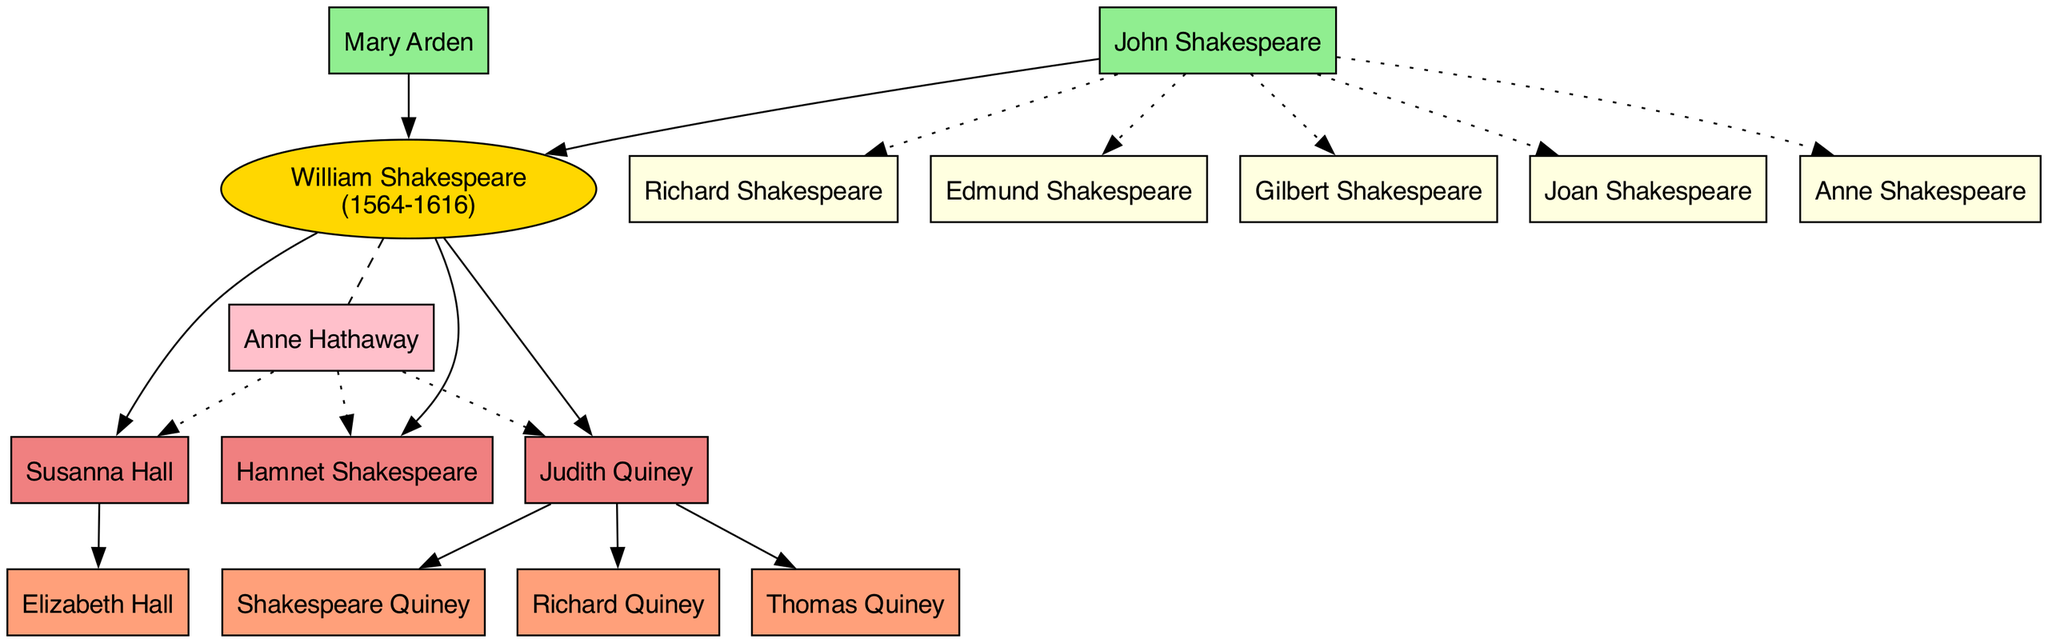What are the names of William Shakespeare's parents? The diagram indicates that William Shakespeare's parents are John Shakespeare and Mary Arden, as represented by the nodes connected directly to him.
Answer: John Shakespeare, Mary Arden How many siblings did William Shakespeare have? By counting the sibling nodes directly connected to William Shakespeare, we find that there are five siblings listed: Gilbert, Joan, Anne, Richard, and Edmund.
Answer: 5 Who is the spouse of William Shakespeare? The diagram shows an edge connecting William Shakespeare to Anne Hathaway, indicating that she is his spouse.
Answer: Anne Hathaway Which child of William Shakespeare has the name "Hall"? The diagram indicates that Susanna Hall is a child of William Shakespeare and her name includes "Hall," as highlighted by the specific connection from him to her.
Answer: Susanna Hall Who are William Shakespeare's grandchildren? By examining the nodes labeled as grandchildren, we find that they are Elizabeth Hall, Shakespeare Quiney, Richard Quiney, and Thomas Quiney connected to the respective nodes of the children.
Answer: Elizabeth Hall, Shakespeare Quiney, Richard Quiney, Thomas Quiney Which sibling of William Shakespeare is connected with a dotted line? The dotted lines in the diagram connect siblings of William Shakespeare to his parents, indicating a different relationship type within his family structure; all siblings are denoted with dotted lines.
Answer: All siblings How many grandchildren did William Shakespeare have in total? By counting the nodes labeled as grandchildren directly connected to his children, we find a total of four grandchildren listed: Elizabeth Hall, Shakespeare Quiney, Richard Quiney, and Thomas Quiney.
Answer: 4 Which child of William Shakespeare is male? The diagram specifies that Hamnet Shakespeare is the only male child of William Shakespeare, as indicated by the name associated with him.
Answer: Hamnet Shakespeare Who is the only daughter of William Shakespeare mentioned in the diagram? Susanna Hall and Judith Quiney are both daughters of William Shakespeare, but asking for "the only" one implies both; however, if counting by a single representative parent linkage, either one could be acceptable. I'll identify Susanna Hall, the first child in the list.
Answer: Susanna Hall 